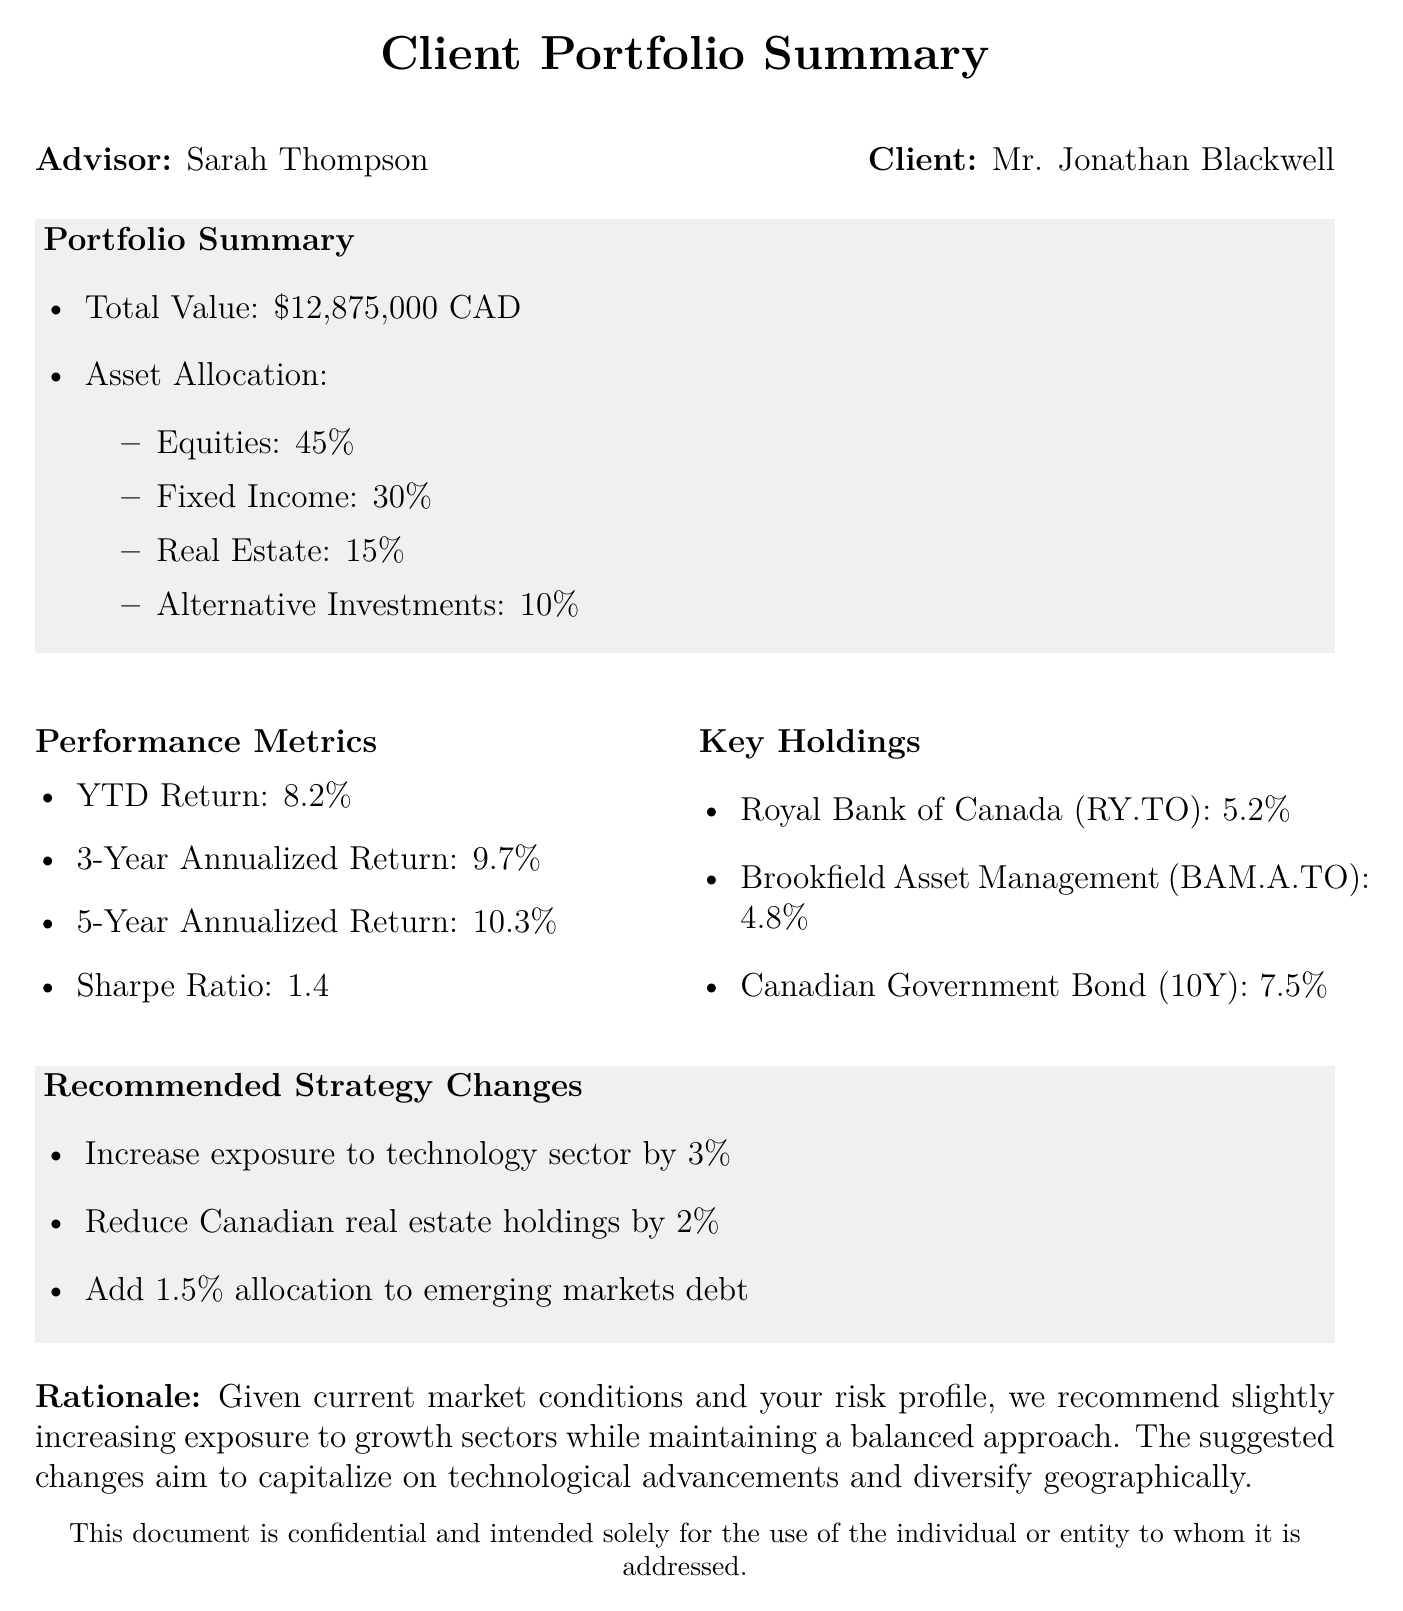What is the total value of the portfolio? The total value is stated as $12,875,000 CAD in the portfolio summary section.
Answer: $12,875,000 CAD What is the YTD return? The YTD return is specified in the performance metrics as 8.2%.
Answer: 8.2% What percentage of the portfolio is allocated to equities? The asset allocation section indicates that equities comprise 45% of the portfolio.
Answer: 45% Who is the financial advisor? The document names Sarah Thompson as the financial advisor.
Answer: Sarah Thompson What is the recommended change for technology sector exposure? The document recommends increasing exposure to the technology sector by 3%.
Answer: Increase by 3% What is the Sharpe Ratio of the portfolio? The Sharpe Ratio is provided in the performance metrics as 1.4.
Answer: 1.4 What is the recommended adjustment for Canadian real estate holdings? The fax suggests reducing Canadian real estate holdings by 2%.
Answer: Reduce by 2% What is the 5-year annualized return? The performance metrics list the 5-year annualized return as 10.3%.
Answer: 10.3% What are the key holdings mentioned in the document? Key holdings are outlined as Royal Bank of Canada, Brookfield Asset Management, and Canadian Government Bond.
Answer: Royal Bank of Canada, Brookfield Asset Management, Canadian Government Bond 